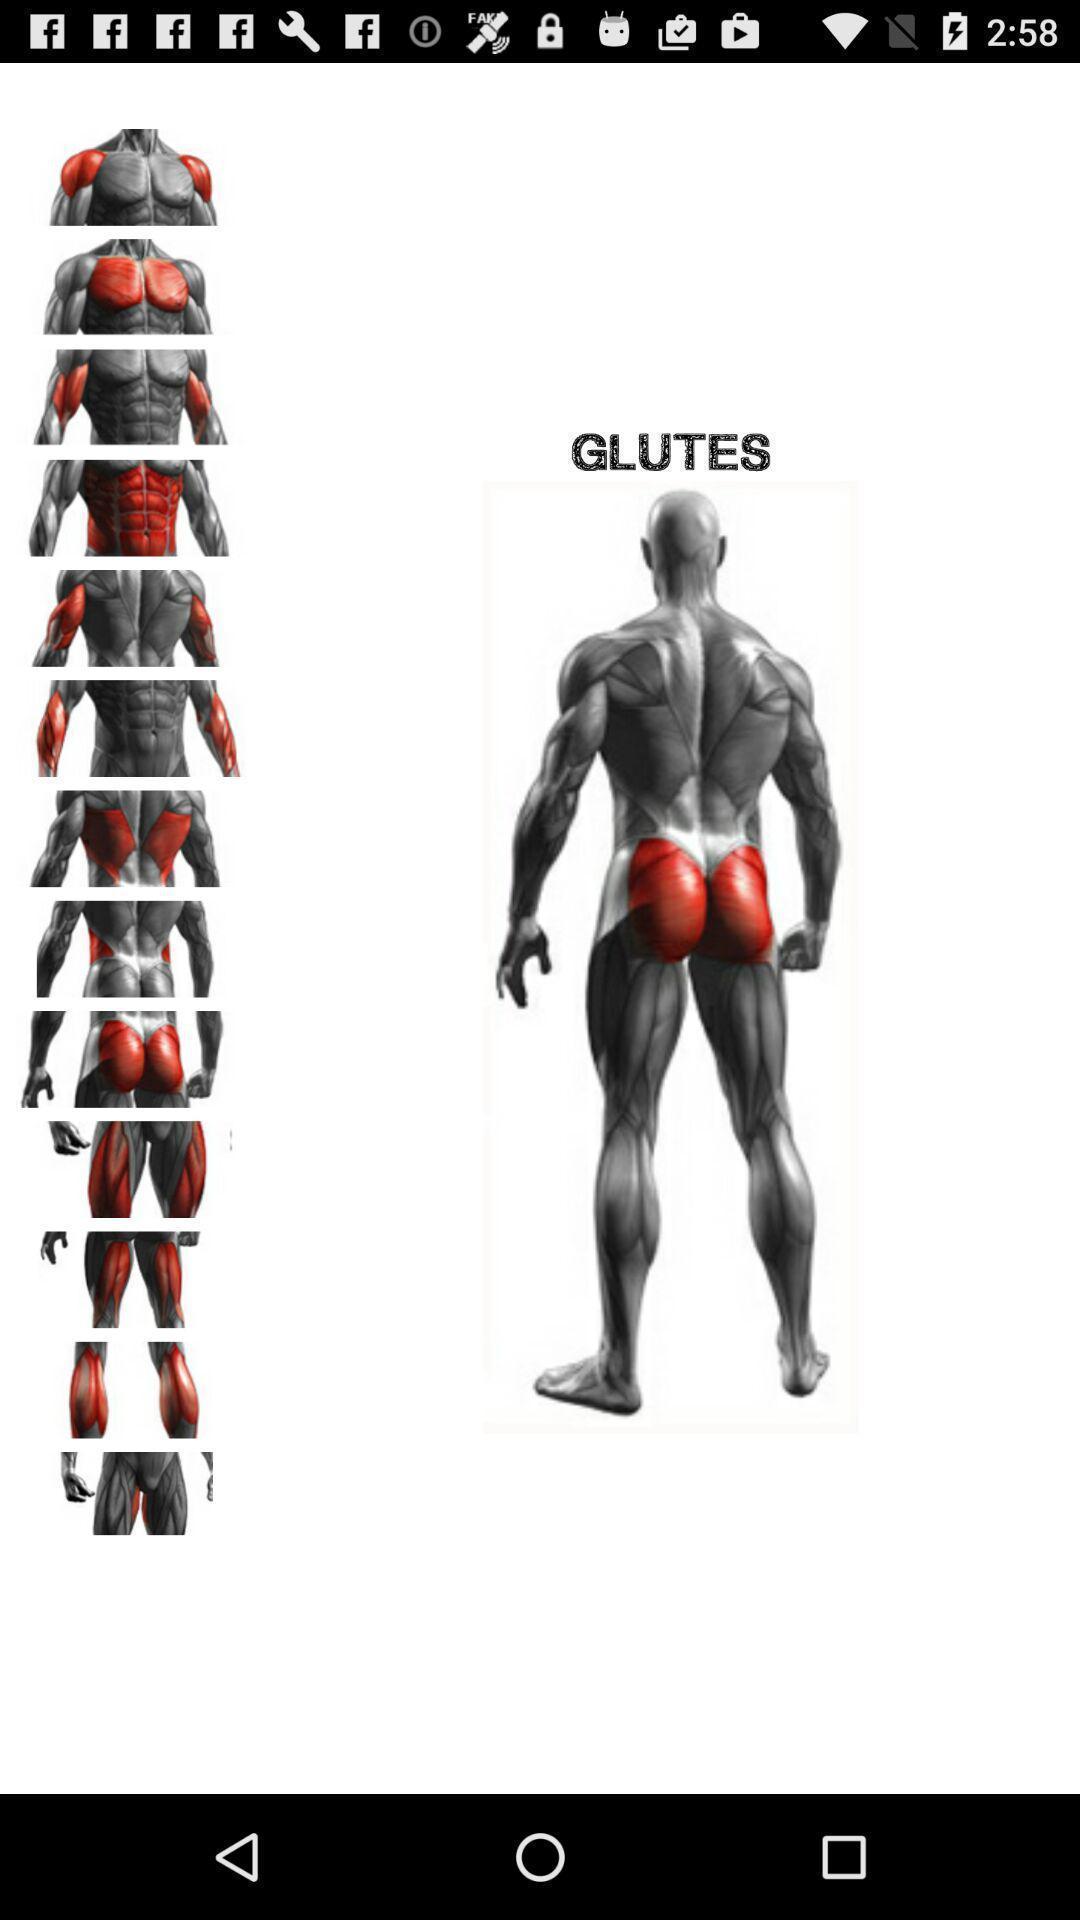Provide a textual representation of this image. Page that displaying bodybuilding image. 